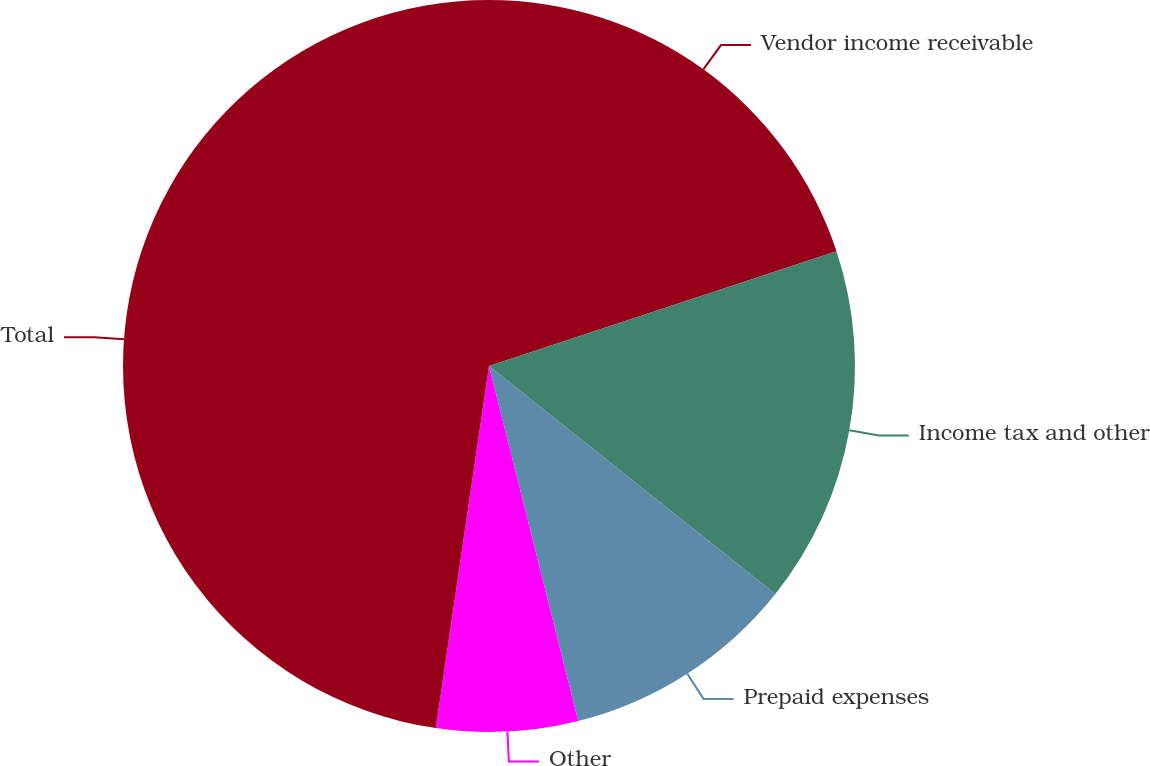<chart> <loc_0><loc_0><loc_500><loc_500><pie_chart><fcel>Vendor income receivable<fcel>Income tax and other<fcel>Prepaid expenses<fcel>Other<fcel>Total<nl><fcel>19.92%<fcel>15.78%<fcel>10.38%<fcel>6.24%<fcel>47.68%<nl></chart> 